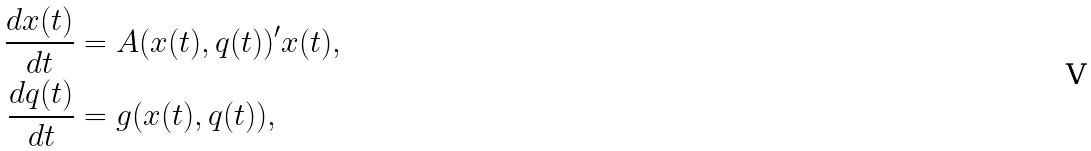Convert formula to latex. <formula><loc_0><loc_0><loc_500><loc_500>\frac { d x ( t ) } { d t } & = A ( x ( t ) , q ( t ) ) ^ { \prime } x ( t ) , \\ \frac { d q ( t ) } { d t } & = g ( x ( t ) , q ( t ) ) ,</formula> 